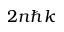<formula> <loc_0><loc_0><loc_500><loc_500>2 n \hbar { k }</formula> 